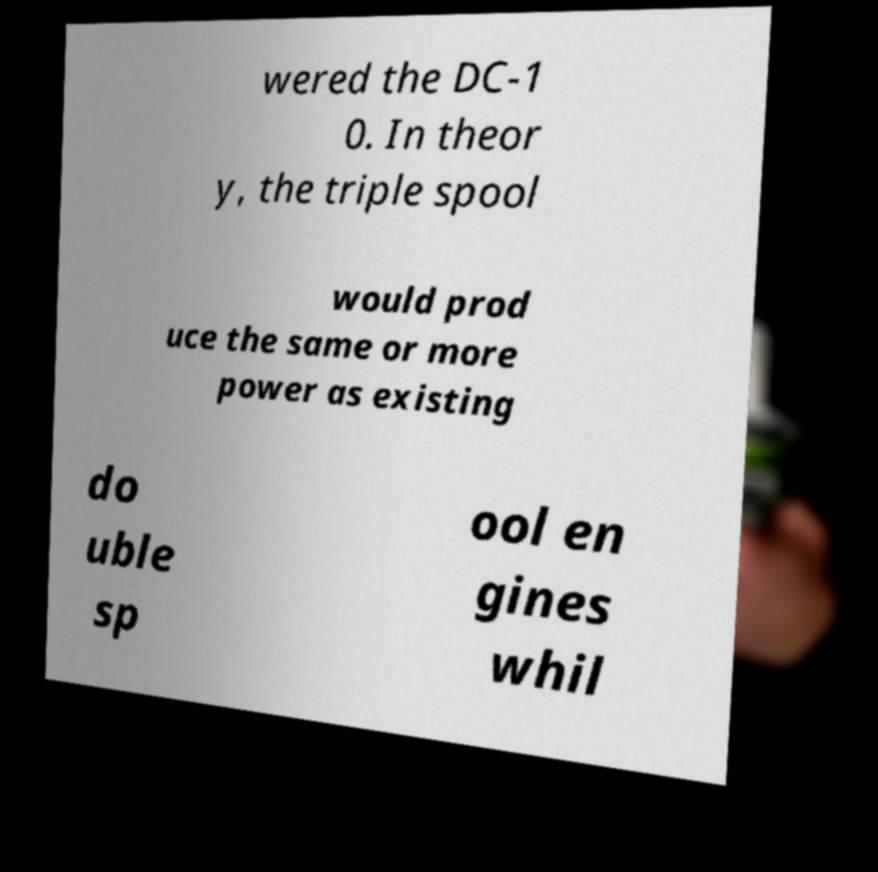Please identify and transcribe the text found in this image. wered the DC-1 0. In theor y, the triple spool would prod uce the same or more power as existing do uble sp ool en gines whil 